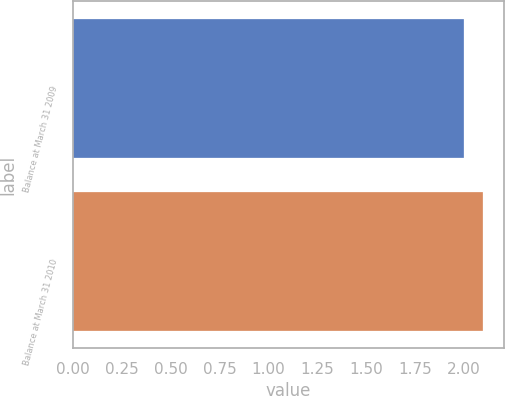Convert chart to OTSL. <chart><loc_0><loc_0><loc_500><loc_500><bar_chart><fcel>Balance at March 31 2009<fcel>Balance at March 31 2010<nl><fcel>2<fcel>2.1<nl></chart> 